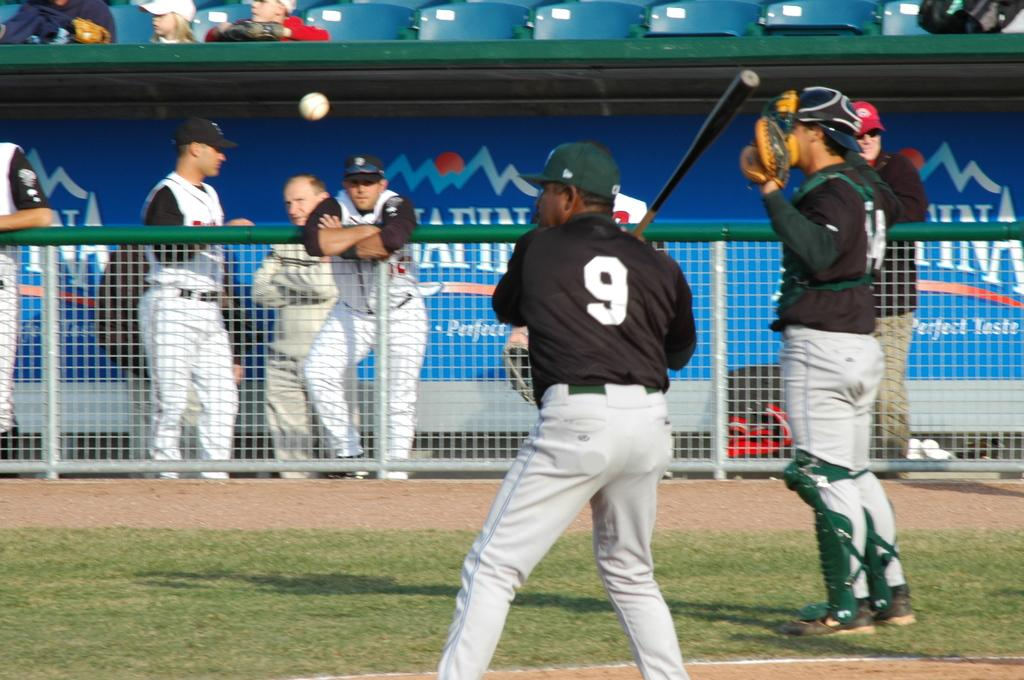<image>
Write a terse but informative summary of the picture. A baseball team at a field sponsored by Aquafina water. 